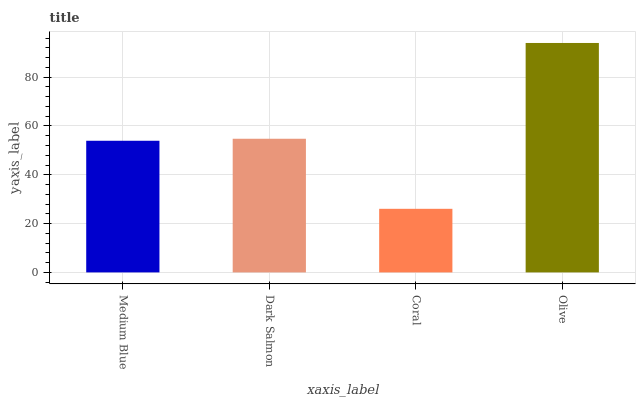Is Coral the minimum?
Answer yes or no. Yes. Is Olive the maximum?
Answer yes or no. Yes. Is Dark Salmon the minimum?
Answer yes or no. No. Is Dark Salmon the maximum?
Answer yes or no. No. Is Dark Salmon greater than Medium Blue?
Answer yes or no. Yes. Is Medium Blue less than Dark Salmon?
Answer yes or no. Yes. Is Medium Blue greater than Dark Salmon?
Answer yes or no. No. Is Dark Salmon less than Medium Blue?
Answer yes or no. No. Is Dark Salmon the high median?
Answer yes or no. Yes. Is Medium Blue the low median?
Answer yes or no. Yes. Is Coral the high median?
Answer yes or no. No. Is Dark Salmon the low median?
Answer yes or no. No. 